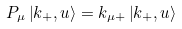<formula> <loc_0><loc_0><loc_500><loc_500>P _ { \mu } \left | k _ { + } , u \right > = k _ { \mu + } \left | k _ { + } , u \right ></formula> 